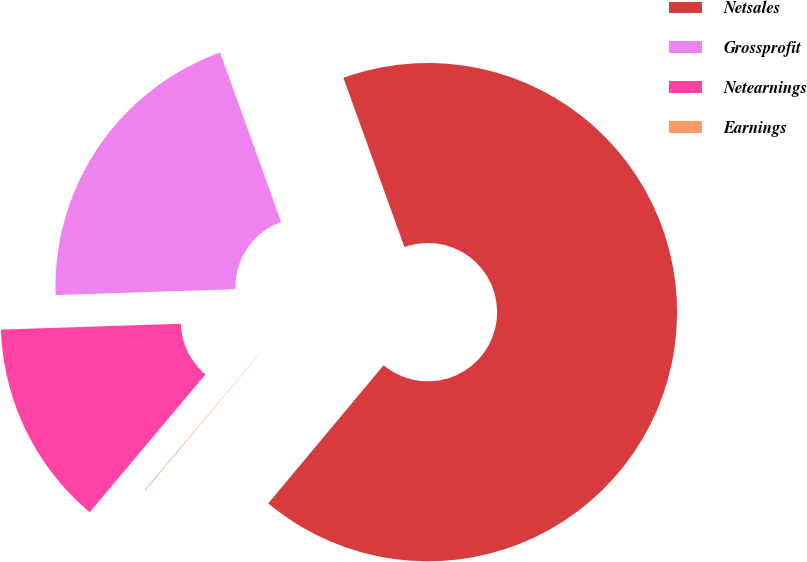<chart> <loc_0><loc_0><loc_500><loc_500><pie_chart><fcel>Netsales<fcel>Grossprofit<fcel>Netearnings<fcel>Earnings<nl><fcel>66.58%<fcel>20.01%<fcel>13.36%<fcel>0.05%<nl></chart> 